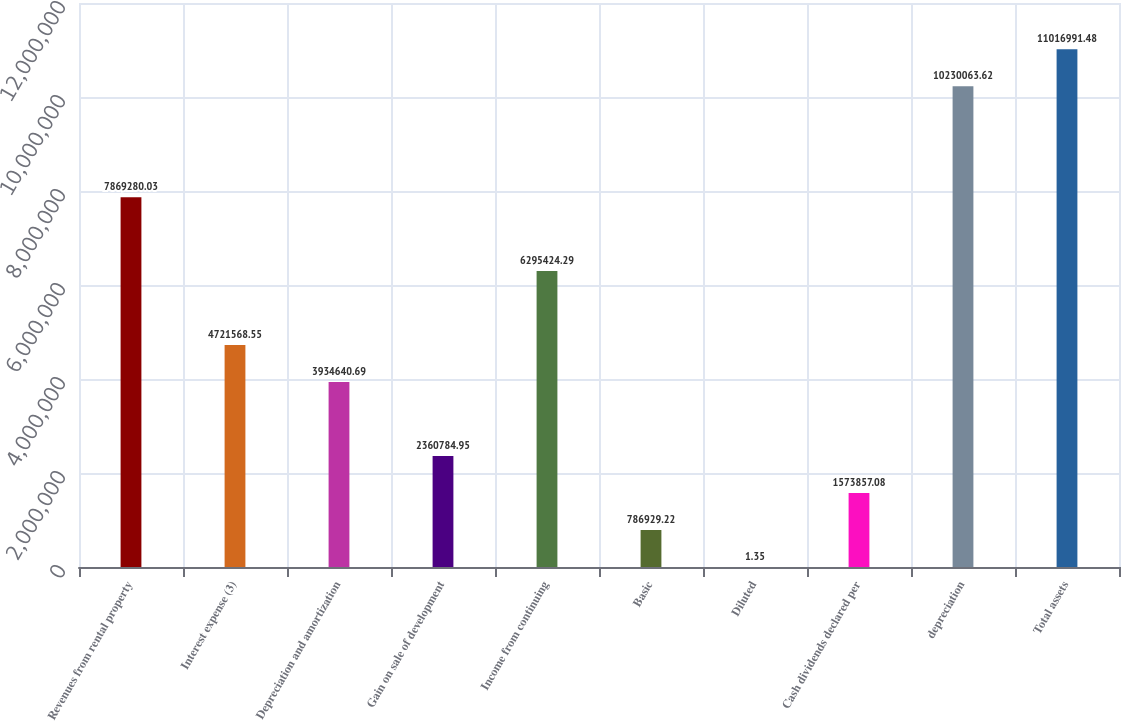Convert chart to OTSL. <chart><loc_0><loc_0><loc_500><loc_500><bar_chart><fcel>Revenues from rental property<fcel>Interest expense (3)<fcel>Depreciation and amortization<fcel>Gain on sale of development<fcel>Income from continuing<fcel>Basic<fcel>Diluted<fcel>Cash dividends declared per<fcel>depreciation<fcel>Total assets<nl><fcel>7.86928e+06<fcel>4.72157e+06<fcel>3.93464e+06<fcel>2.36078e+06<fcel>6.29542e+06<fcel>786929<fcel>1.35<fcel>1.57386e+06<fcel>1.02301e+07<fcel>1.1017e+07<nl></chart> 